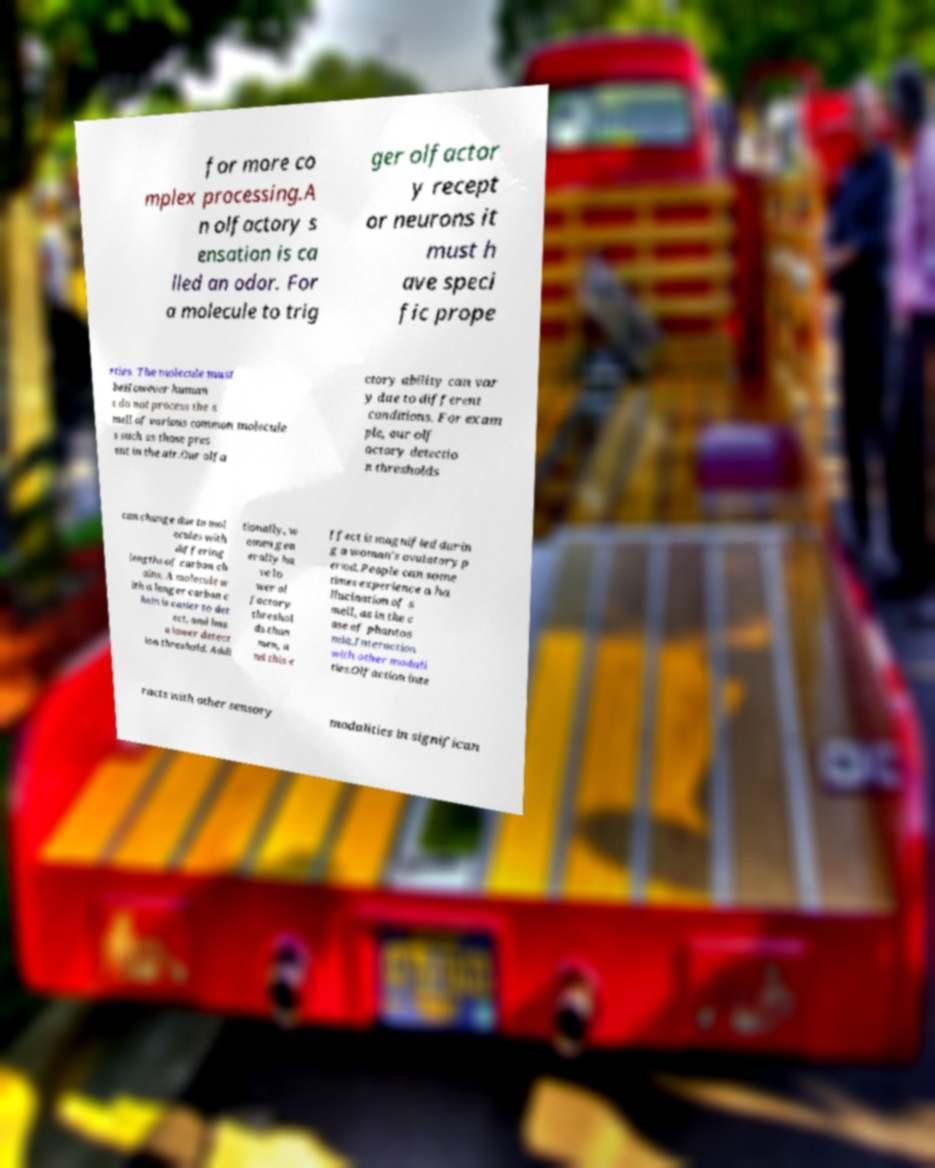Could you assist in decoding the text presented in this image and type it out clearly? for more co mplex processing.A n olfactory s ensation is ca lled an odor. For a molecule to trig ger olfactor y recept or neurons it must h ave speci fic prope rties. The molecule must beHowever human s do not process the s mell of various common molecule s such as those pres ent in the air.Our olfa ctory ability can var y due to different conditions. For exam ple, our olf actory detectio n thresholds can change due to mol ecules with differing lengths of carbon ch ains. A molecule w ith a longer carbon c hain is easier to det ect, and has a lower detect ion threshold. Addi tionally, w omen gen erally ha ve lo wer ol factory threshol ds than men, a nd this e ffect is magnified durin g a woman's ovulatory p eriod. People can some times experience a ha llucination of s mell, as in the c ase of phantos mia.Interaction with other modali ties.Olfaction inte racts with other sensory modalities in significan 